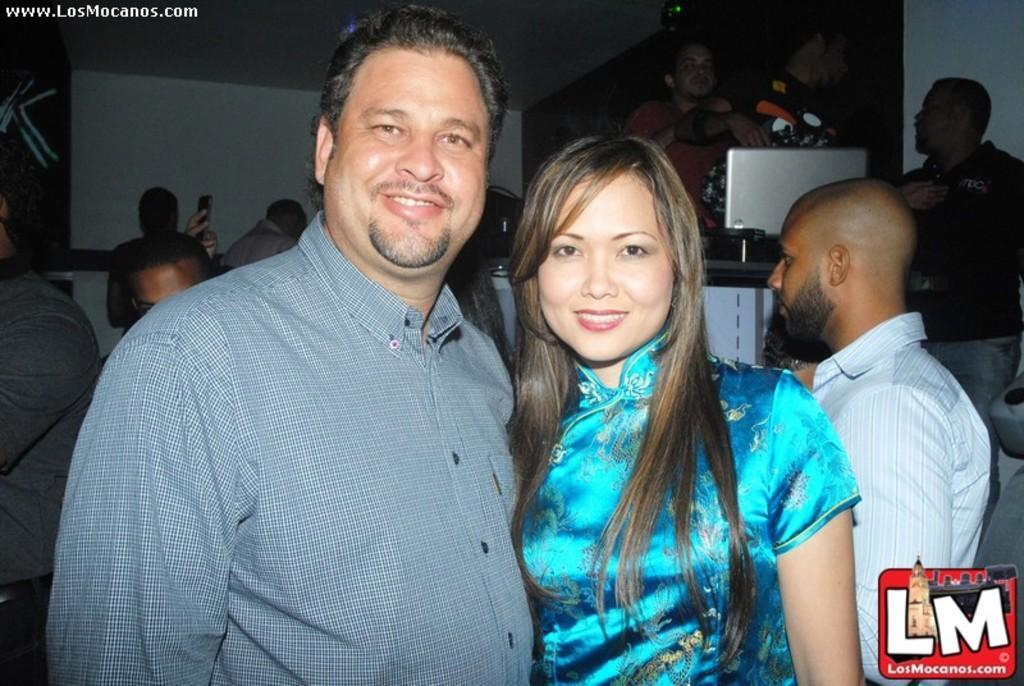Can you describe this image briefly? In this image we can see people standing. 